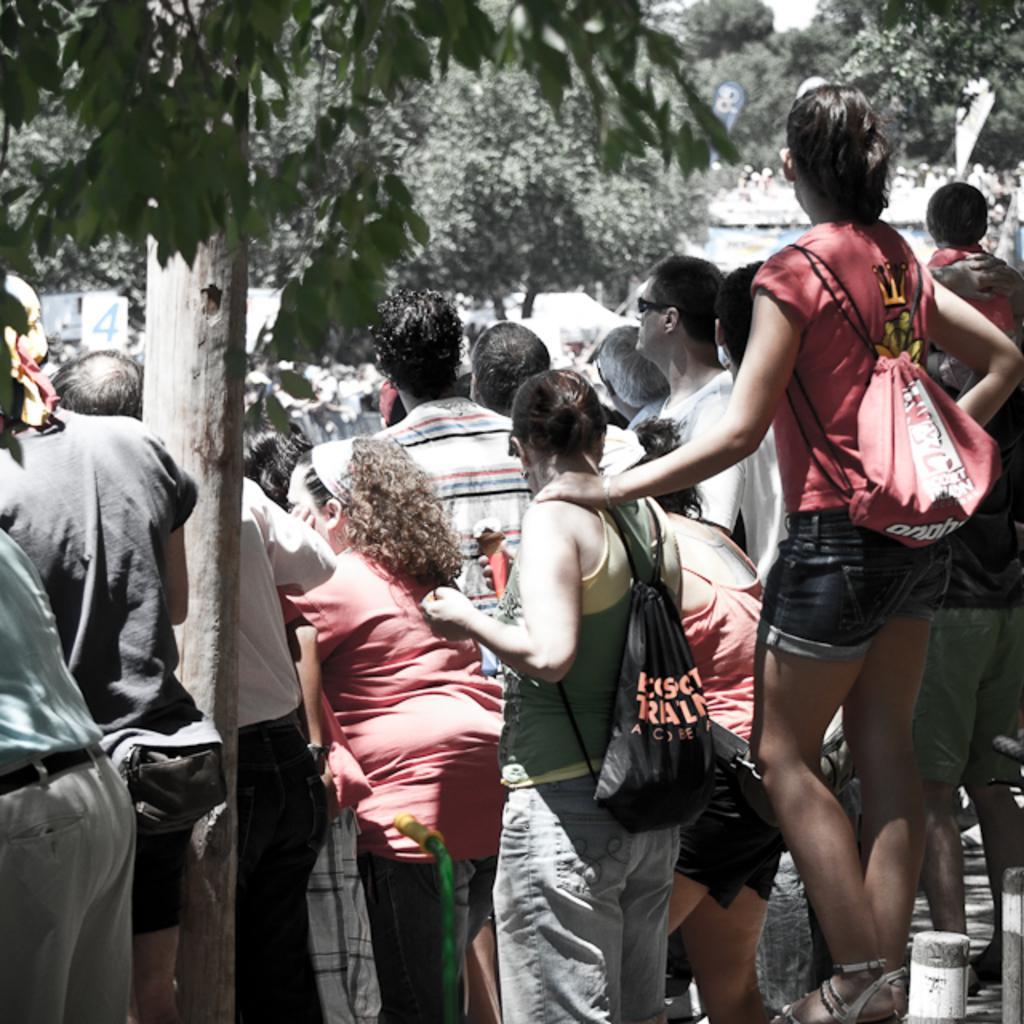In one or two sentences, can you explain what this image depicts? In the image in the center we can see a group of people were standing and few people were wearing backpacks. On the bottom right of the image,we can see two poles. In the background we can see trees,banners etc. 